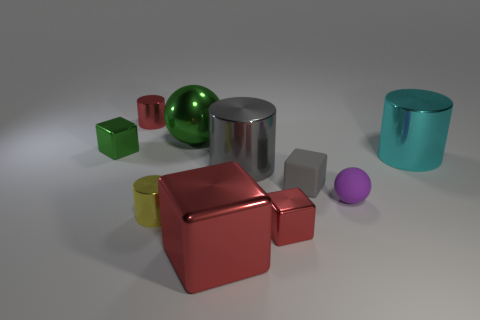There is a object that is the same color as the rubber block; what is its size?
Offer a very short reply. Large. Does the matte block have the same color as the tiny sphere?
Give a very brief answer. No. What shape is the metal object that is both in front of the large gray shiny cylinder and right of the large gray metallic cylinder?
Make the answer very short. Cube. Are there any large metallic cylinders that have the same color as the matte block?
Your answer should be compact. Yes. Is there a tiny rubber cylinder?
Your answer should be very brief. No. The small shiny thing that is on the right side of the metallic sphere is what color?
Provide a short and direct response. Red. There is a yellow metallic thing; is it the same size as the green object that is on the left side of the shiny ball?
Ensure brevity in your answer.  Yes. How big is the cylinder that is to the left of the gray metal cylinder and on the right side of the small red cylinder?
Make the answer very short. Small. Is there a large sphere made of the same material as the small yellow cylinder?
Your answer should be compact. Yes. What is the shape of the tiny green metallic object?
Provide a short and direct response. Cube. 